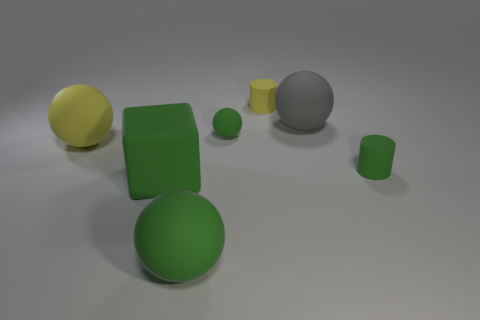There is a big matte cube; what number of large rubber balls are behind it?
Offer a terse response. 2. Are there fewer large spheres behind the big gray matte thing than green rubber spheres behind the matte cube?
Offer a terse response. Yes. The yellow object to the right of the green matte sphere that is behind the cylinder that is to the right of the large gray thing is what shape?
Your answer should be compact. Cylinder. There is a big object that is on the left side of the yellow matte cylinder and on the right side of the big rubber block; what shape is it?
Give a very brief answer. Sphere. Is there a cube that has the same material as the yellow cylinder?
Make the answer very short. Yes. The matte cylinder that is the same color as the tiny matte ball is what size?
Your answer should be compact. Small. There is a big matte sphere in front of the green matte cube; what color is it?
Provide a succinct answer. Green. Do the big yellow object and the small green thing on the left side of the large gray matte ball have the same shape?
Offer a very short reply. Yes. Are there any tiny cylinders that have the same color as the big matte block?
Keep it short and to the point. Yes. There is a green cube that is the same material as the big gray object; what size is it?
Your answer should be very brief. Large. 